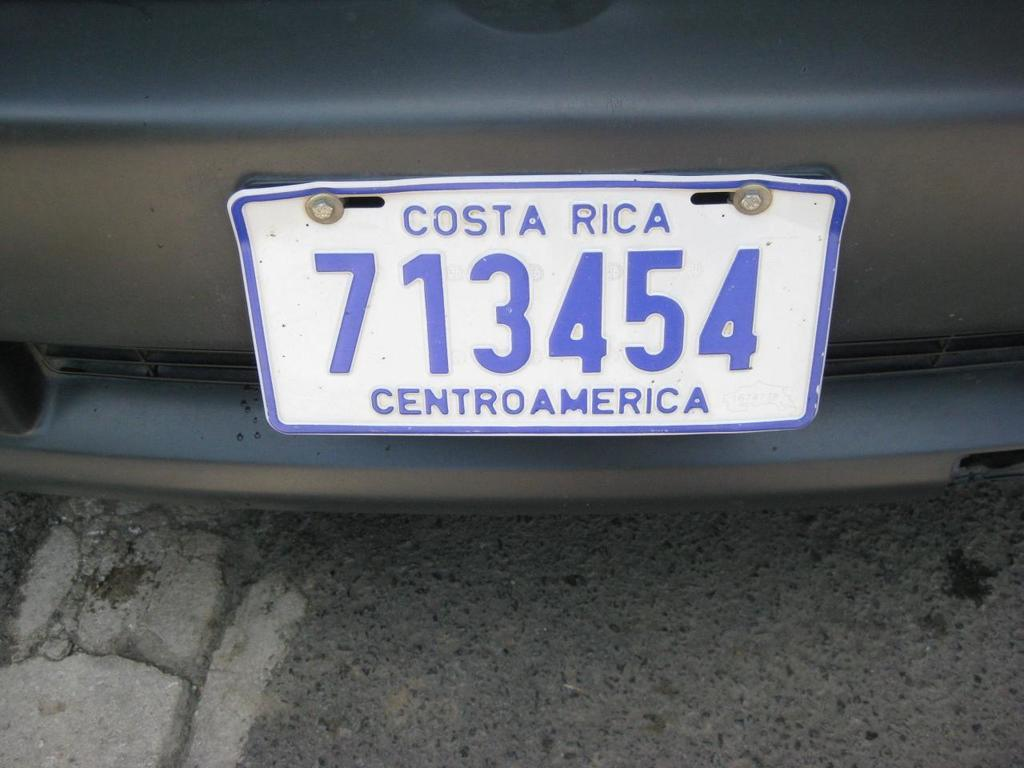<image>
Relay a brief, clear account of the picture shown. A Blue and white license plate from Costa Rica is screwed onto a dark grey bumper. 